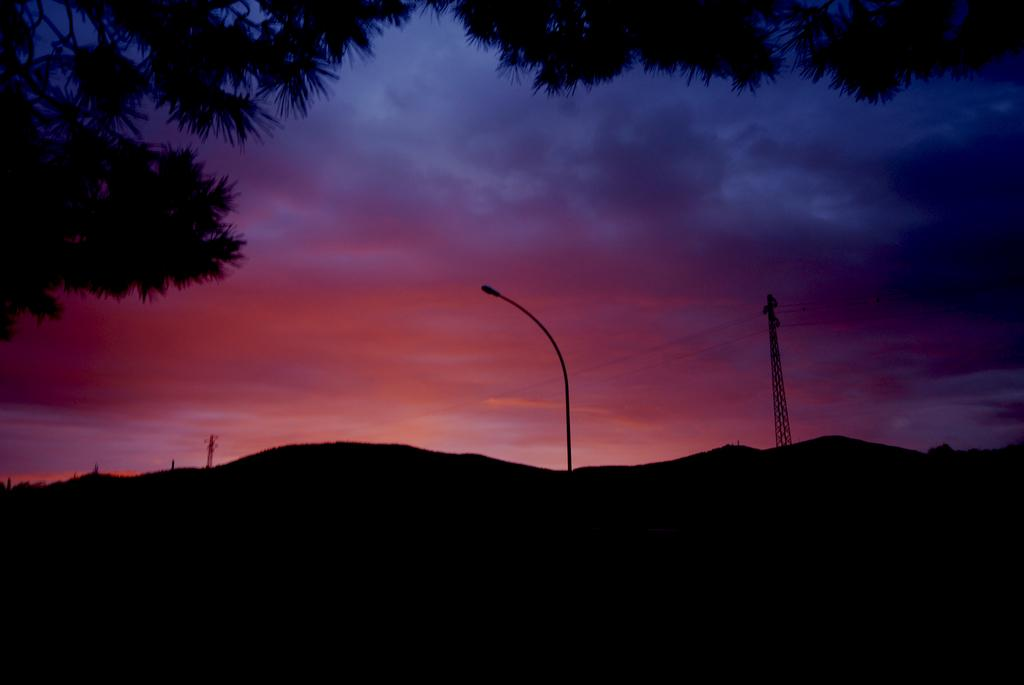What is the main structure in the center of the image? There is a light pole in the center of the image. What other objects can be seen in the image? There are metal frames with cables in the image. What can be seen in the background of the image? There are mountains, trees, and a cloudy sky in the background of the image. Where is the person sleeping under the sheet in the image? There is no person sleeping under a sheet present in the image. What type of hill can be seen in the image? There is no hill visible in the image; it features a light pole, metal frames with cables, and a background with mountains, trees, and a cloudy sky. 